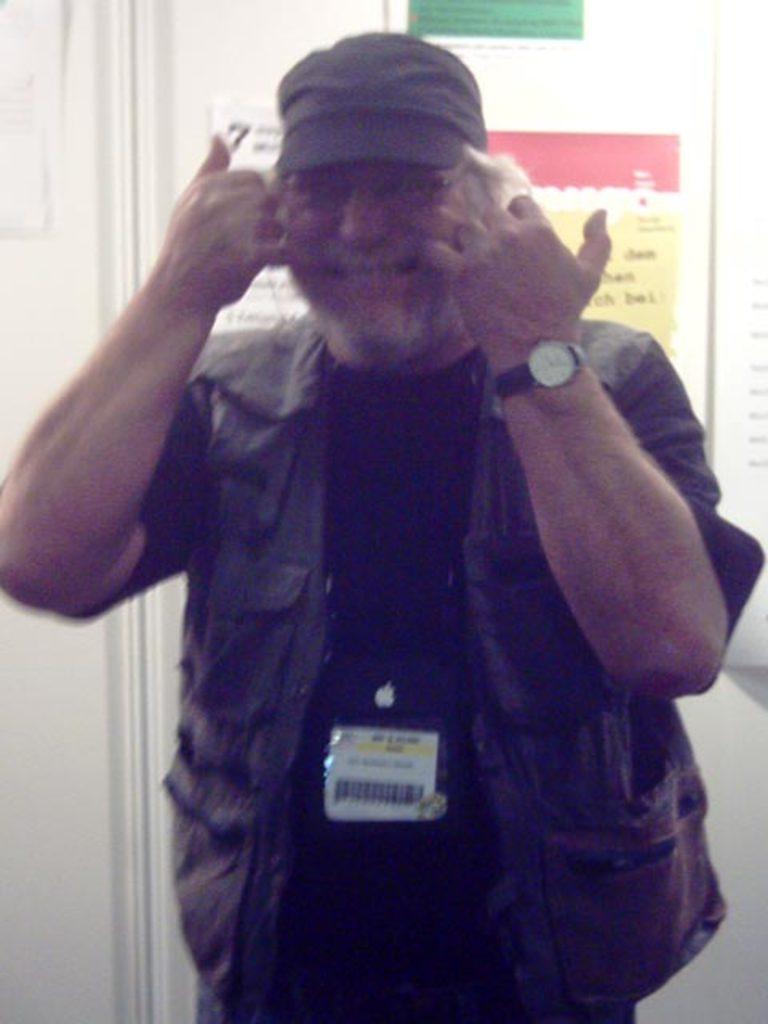Describe this image in one or two sentences. In this image we can see a man wearing the cap and also the watch and smiling. In the background we can see the posters with the text attached to the wall. We can also see the text to the card and the man is wearing the text card. 